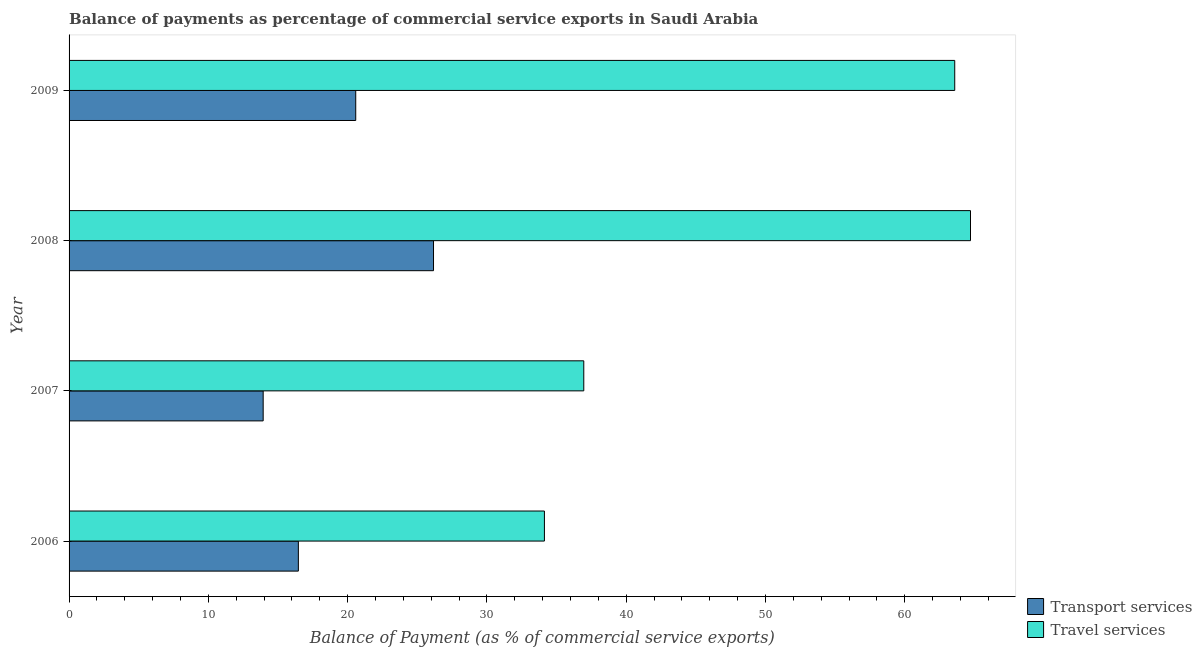Are the number of bars per tick equal to the number of legend labels?
Offer a terse response. Yes. How many bars are there on the 3rd tick from the top?
Your answer should be compact. 2. What is the label of the 3rd group of bars from the top?
Keep it short and to the point. 2007. In how many cases, is the number of bars for a given year not equal to the number of legend labels?
Make the answer very short. 0. What is the balance of payments of travel services in 2007?
Offer a very short reply. 36.95. Across all years, what is the maximum balance of payments of transport services?
Your answer should be very brief. 26.16. Across all years, what is the minimum balance of payments of transport services?
Provide a short and direct response. 13.94. In which year was the balance of payments of transport services maximum?
Keep it short and to the point. 2008. What is the total balance of payments of travel services in the graph?
Provide a succinct answer. 199.38. What is the difference between the balance of payments of transport services in 2008 and that in 2009?
Your answer should be very brief. 5.58. What is the difference between the balance of payments of transport services in 2009 and the balance of payments of travel services in 2007?
Offer a terse response. -16.37. What is the average balance of payments of travel services per year?
Your answer should be very brief. 49.84. In the year 2008, what is the difference between the balance of payments of travel services and balance of payments of transport services?
Ensure brevity in your answer.  38.55. What is the ratio of the balance of payments of travel services in 2006 to that in 2008?
Your answer should be very brief. 0.53. Is the difference between the balance of payments of transport services in 2007 and 2009 greater than the difference between the balance of payments of travel services in 2007 and 2009?
Your answer should be very brief. Yes. What is the difference between the highest and the second highest balance of payments of transport services?
Keep it short and to the point. 5.58. What is the difference between the highest and the lowest balance of payments of travel services?
Make the answer very short. 30.59. Is the sum of the balance of payments of travel services in 2007 and 2009 greater than the maximum balance of payments of transport services across all years?
Offer a terse response. Yes. What does the 2nd bar from the top in 2009 represents?
Provide a succinct answer. Transport services. What does the 1st bar from the bottom in 2008 represents?
Your answer should be very brief. Transport services. How many bars are there?
Offer a very short reply. 8. How many years are there in the graph?
Provide a short and direct response. 4. What is the difference between two consecutive major ticks on the X-axis?
Your answer should be compact. 10. Does the graph contain grids?
Provide a short and direct response. No. Where does the legend appear in the graph?
Your response must be concise. Bottom right. How are the legend labels stacked?
Your answer should be compact. Vertical. What is the title of the graph?
Keep it short and to the point. Balance of payments as percentage of commercial service exports in Saudi Arabia. Does "Exports of goods" appear as one of the legend labels in the graph?
Provide a succinct answer. No. What is the label or title of the X-axis?
Your response must be concise. Balance of Payment (as % of commercial service exports). What is the Balance of Payment (as % of commercial service exports) of Transport services in 2006?
Your response must be concise. 16.46. What is the Balance of Payment (as % of commercial service exports) in Travel services in 2006?
Offer a very short reply. 34.13. What is the Balance of Payment (as % of commercial service exports) of Transport services in 2007?
Offer a very short reply. 13.94. What is the Balance of Payment (as % of commercial service exports) in Travel services in 2007?
Provide a short and direct response. 36.95. What is the Balance of Payment (as % of commercial service exports) of Transport services in 2008?
Make the answer very short. 26.16. What is the Balance of Payment (as % of commercial service exports) of Travel services in 2008?
Offer a very short reply. 64.72. What is the Balance of Payment (as % of commercial service exports) in Transport services in 2009?
Keep it short and to the point. 20.58. What is the Balance of Payment (as % of commercial service exports) of Travel services in 2009?
Keep it short and to the point. 63.58. Across all years, what is the maximum Balance of Payment (as % of commercial service exports) in Transport services?
Your answer should be compact. 26.16. Across all years, what is the maximum Balance of Payment (as % of commercial service exports) in Travel services?
Make the answer very short. 64.72. Across all years, what is the minimum Balance of Payment (as % of commercial service exports) in Transport services?
Keep it short and to the point. 13.94. Across all years, what is the minimum Balance of Payment (as % of commercial service exports) of Travel services?
Your answer should be compact. 34.13. What is the total Balance of Payment (as % of commercial service exports) in Transport services in the graph?
Your answer should be compact. 77.14. What is the total Balance of Payment (as % of commercial service exports) in Travel services in the graph?
Keep it short and to the point. 199.38. What is the difference between the Balance of Payment (as % of commercial service exports) in Transport services in 2006 and that in 2007?
Offer a terse response. 2.53. What is the difference between the Balance of Payment (as % of commercial service exports) in Travel services in 2006 and that in 2007?
Provide a short and direct response. -2.82. What is the difference between the Balance of Payment (as % of commercial service exports) of Transport services in 2006 and that in 2008?
Offer a terse response. -9.7. What is the difference between the Balance of Payment (as % of commercial service exports) in Travel services in 2006 and that in 2008?
Provide a succinct answer. -30.59. What is the difference between the Balance of Payment (as % of commercial service exports) in Transport services in 2006 and that in 2009?
Your response must be concise. -4.12. What is the difference between the Balance of Payment (as % of commercial service exports) of Travel services in 2006 and that in 2009?
Your response must be concise. -29.46. What is the difference between the Balance of Payment (as % of commercial service exports) of Transport services in 2007 and that in 2008?
Give a very brief answer. -12.23. What is the difference between the Balance of Payment (as % of commercial service exports) of Travel services in 2007 and that in 2008?
Offer a terse response. -27.76. What is the difference between the Balance of Payment (as % of commercial service exports) in Transport services in 2007 and that in 2009?
Offer a very short reply. -6.65. What is the difference between the Balance of Payment (as % of commercial service exports) of Travel services in 2007 and that in 2009?
Your answer should be compact. -26.63. What is the difference between the Balance of Payment (as % of commercial service exports) of Transport services in 2008 and that in 2009?
Ensure brevity in your answer.  5.58. What is the difference between the Balance of Payment (as % of commercial service exports) in Travel services in 2008 and that in 2009?
Give a very brief answer. 1.13. What is the difference between the Balance of Payment (as % of commercial service exports) of Transport services in 2006 and the Balance of Payment (as % of commercial service exports) of Travel services in 2007?
Your answer should be very brief. -20.49. What is the difference between the Balance of Payment (as % of commercial service exports) in Transport services in 2006 and the Balance of Payment (as % of commercial service exports) in Travel services in 2008?
Provide a short and direct response. -48.25. What is the difference between the Balance of Payment (as % of commercial service exports) of Transport services in 2006 and the Balance of Payment (as % of commercial service exports) of Travel services in 2009?
Ensure brevity in your answer.  -47.12. What is the difference between the Balance of Payment (as % of commercial service exports) in Transport services in 2007 and the Balance of Payment (as % of commercial service exports) in Travel services in 2008?
Make the answer very short. -50.78. What is the difference between the Balance of Payment (as % of commercial service exports) in Transport services in 2007 and the Balance of Payment (as % of commercial service exports) in Travel services in 2009?
Provide a short and direct response. -49.65. What is the difference between the Balance of Payment (as % of commercial service exports) in Transport services in 2008 and the Balance of Payment (as % of commercial service exports) in Travel services in 2009?
Keep it short and to the point. -37.42. What is the average Balance of Payment (as % of commercial service exports) in Transport services per year?
Your response must be concise. 19.29. What is the average Balance of Payment (as % of commercial service exports) in Travel services per year?
Your answer should be compact. 49.84. In the year 2006, what is the difference between the Balance of Payment (as % of commercial service exports) in Transport services and Balance of Payment (as % of commercial service exports) in Travel services?
Provide a short and direct response. -17.67. In the year 2007, what is the difference between the Balance of Payment (as % of commercial service exports) in Transport services and Balance of Payment (as % of commercial service exports) in Travel services?
Your answer should be very brief. -23.02. In the year 2008, what is the difference between the Balance of Payment (as % of commercial service exports) in Transport services and Balance of Payment (as % of commercial service exports) in Travel services?
Your answer should be compact. -38.55. In the year 2009, what is the difference between the Balance of Payment (as % of commercial service exports) in Transport services and Balance of Payment (as % of commercial service exports) in Travel services?
Ensure brevity in your answer.  -43. What is the ratio of the Balance of Payment (as % of commercial service exports) in Transport services in 2006 to that in 2007?
Give a very brief answer. 1.18. What is the ratio of the Balance of Payment (as % of commercial service exports) in Travel services in 2006 to that in 2007?
Your response must be concise. 0.92. What is the ratio of the Balance of Payment (as % of commercial service exports) of Transport services in 2006 to that in 2008?
Offer a terse response. 0.63. What is the ratio of the Balance of Payment (as % of commercial service exports) of Travel services in 2006 to that in 2008?
Ensure brevity in your answer.  0.53. What is the ratio of the Balance of Payment (as % of commercial service exports) in Transport services in 2006 to that in 2009?
Your response must be concise. 0.8. What is the ratio of the Balance of Payment (as % of commercial service exports) of Travel services in 2006 to that in 2009?
Provide a short and direct response. 0.54. What is the ratio of the Balance of Payment (as % of commercial service exports) of Transport services in 2007 to that in 2008?
Make the answer very short. 0.53. What is the ratio of the Balance of Payment (as % of commercial service exports) of Travel services in 2007 to that in 2008?
Give a very brief answer. 0.57. What is the ratio of the Balance of Payment (as % of commercial service exports) in Transport services in 2007 to that in 2009?
Offer a terse response. 0.68. What is the ratio of the Balance of Payment (as % of commercial service exports) in Travel services in 2007 to that in 2009?
Offer a very short reply. 0.58. What is the ratio of the Balance of Payment (as % of commercial service exports) in Transport services in 2008 to that in 2009?
Your response must be concise. 1.27. What is the ratio of the Balance of Payment (as % of commercial service exports) of Travel services in 2008 to that in 2009?
Give a very brief answer. 1.02. What is the difference between the highest and the second highest Balance of Payment (as % of commercial service exports) of Transport services?
Make the answer very short. 5.58. What is the difference between the highest and the second highest Balance of Payment (as % of commercial service exports) of Travel services?
Your response must be concise. 1.13. What is the difference between the highest and the lowest Balance of Payment (as % of commercial service exports) in Transport services?
Provide a short and direct response. 12.23. What is the difference between the highest and the lowest Balance of Payment (as % of commercial service exports) in Travel services?
Keep it short and to the point. 30.59. 